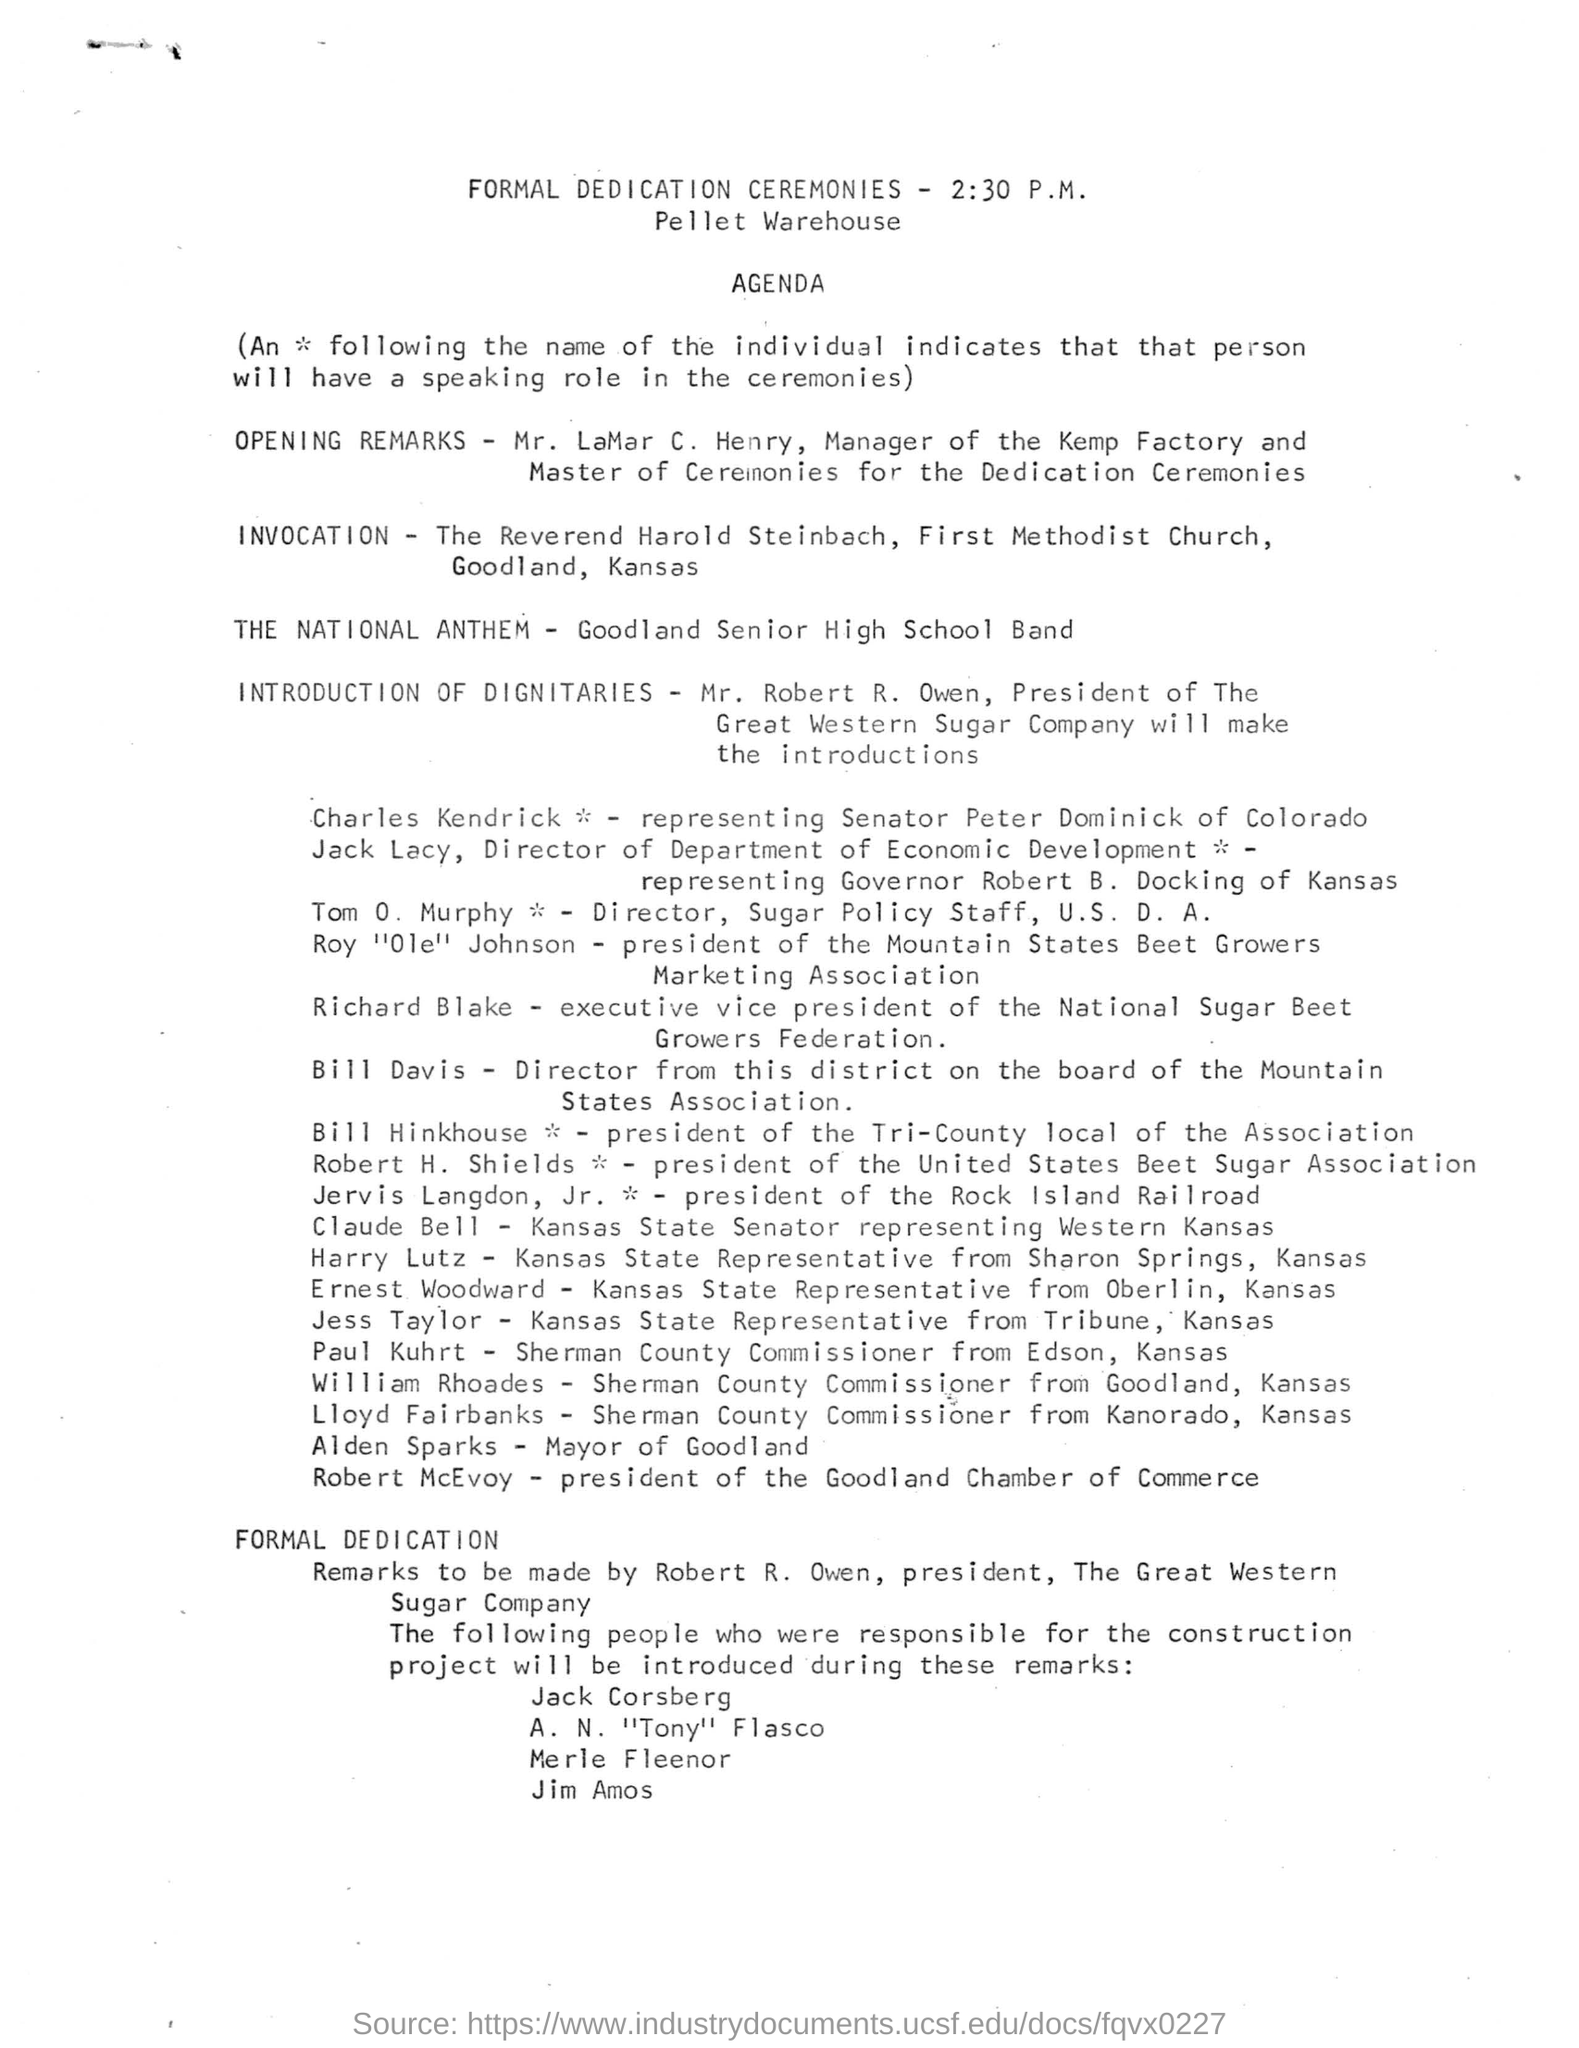Outline some significant characteristics in this image. The formal dedication ceremonies for the PELLET WAREHOUSE will be held at the specified location. The executive vice president of the National Sugar Beet Growers Federation is Richard Blake. It is announced that Mr. Robert R. Owen will be giving the introduction of dignitaries. The formal dedication ceremonies will be held at 2:30 P.M. The Goodland Senior High School Band will be performing the National Anthem. 